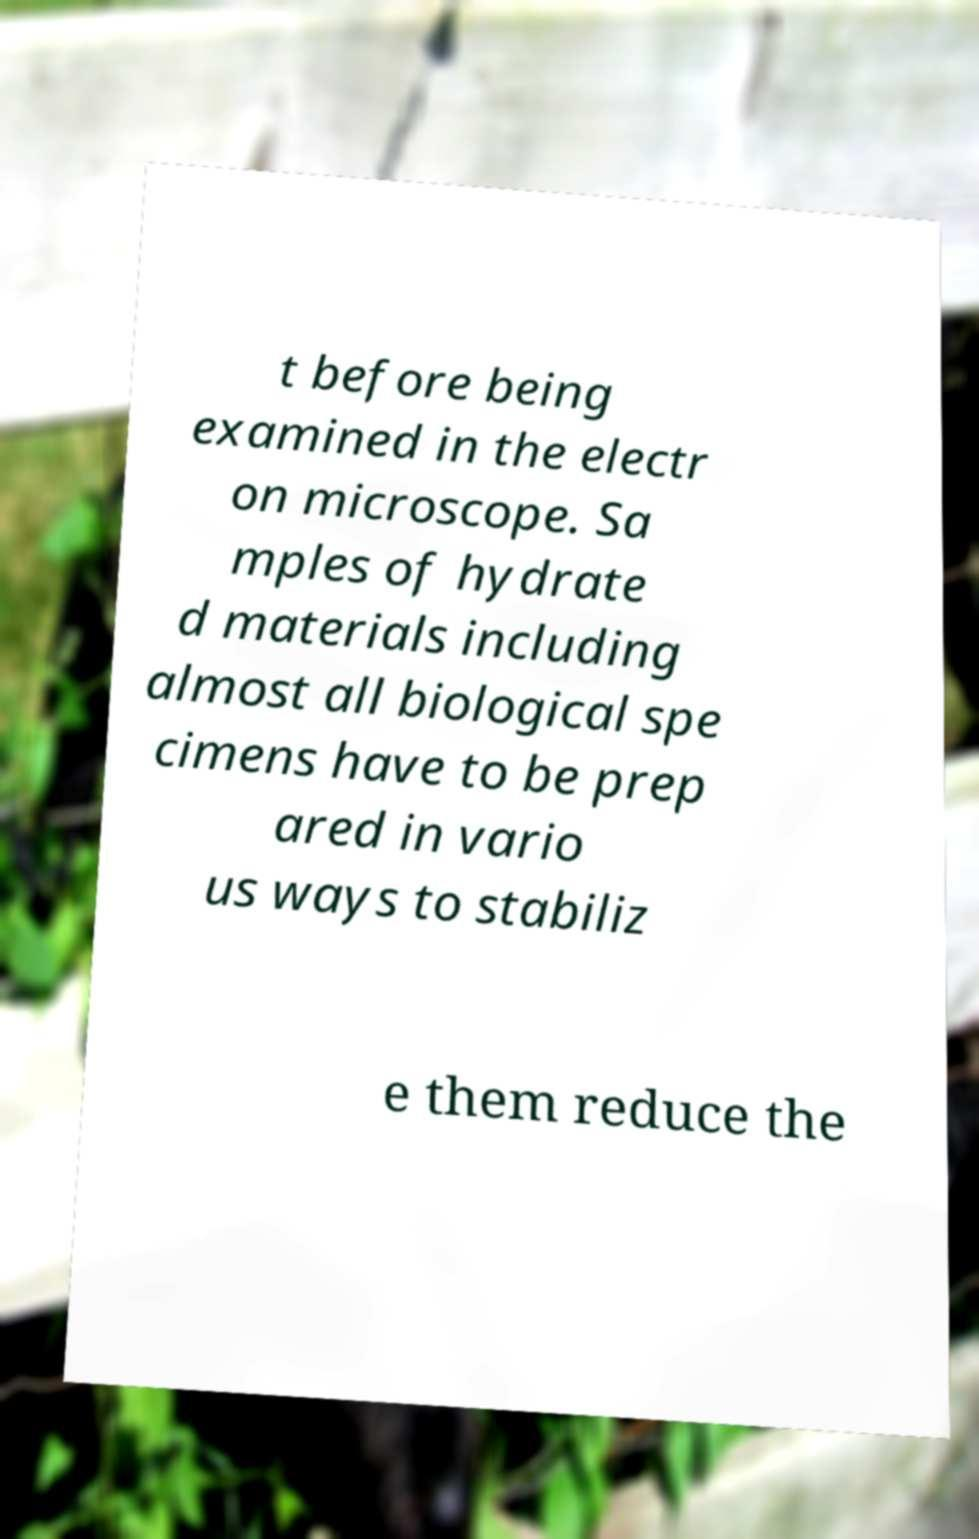For documentation purposes, I need the text within this image transcribed. Could you provide that? t before being examined in the electr on microscope. Sa mples of hydrate d materials including almost all biological spe cimens have to be prep ared in vario us ways to stabiliz e them reduce the 